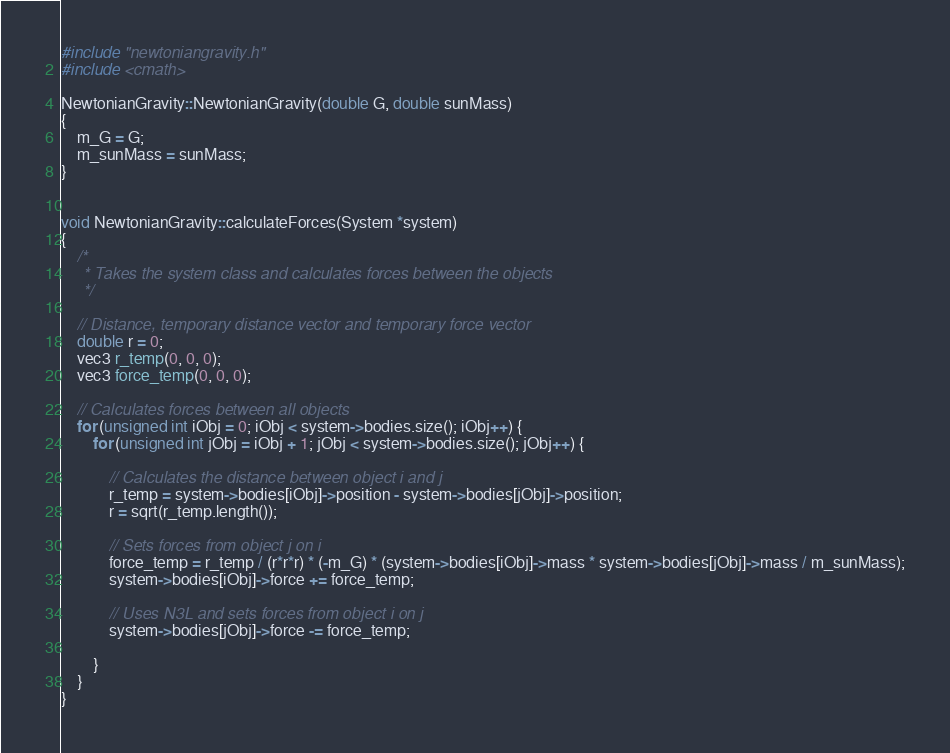<code> <loc_0><loc_0><loc_500><loc_500><_C++_>#include "newtoniangravity.h"
#include <cmath>

NewtonianGravity::NewtonianGravity(double G, double sunMass)
{
    m_G = G;
    m_sunMass = sunMass;
}


void NewtonianGravity::calculateForces(System *system)
{
    /*
     * Takes the system class and calculates forces between the objects
     */

    // Distance, temporary distance vector and temporary force vector
    double r = 0;
    vec3 r_temp(0, 0, 0);
    vec3 force_temp(0, 0, 0);

    // Calculates forces between all objects
    for (unsigned int iObj = 0; iObj < system->bodies.size(); iObj++) {
        for (unsigned int jObj = iObj + 1; jObj < system->bodies.size(); jObj++) {

            // Calculates the distance between object i and j
            r_temp = system->bodies[iObj]->position - system->bodies[jObj]->position;
            r = sqrt(r_temp.length());

            // Sets forces from object j on i
            force_temp = r_temp / (r*r*r) * (-m_G) * (system->bodies[iObj]->mass * system->bodies[jObj]->mass / m_sunMass);
            system->bodies[iObj]->force += force_temp;

            // Uses N3L and sets forces from object i on j
            system->bodies[jObj]->force -= force_temp;

        }
    }
}
</code> 